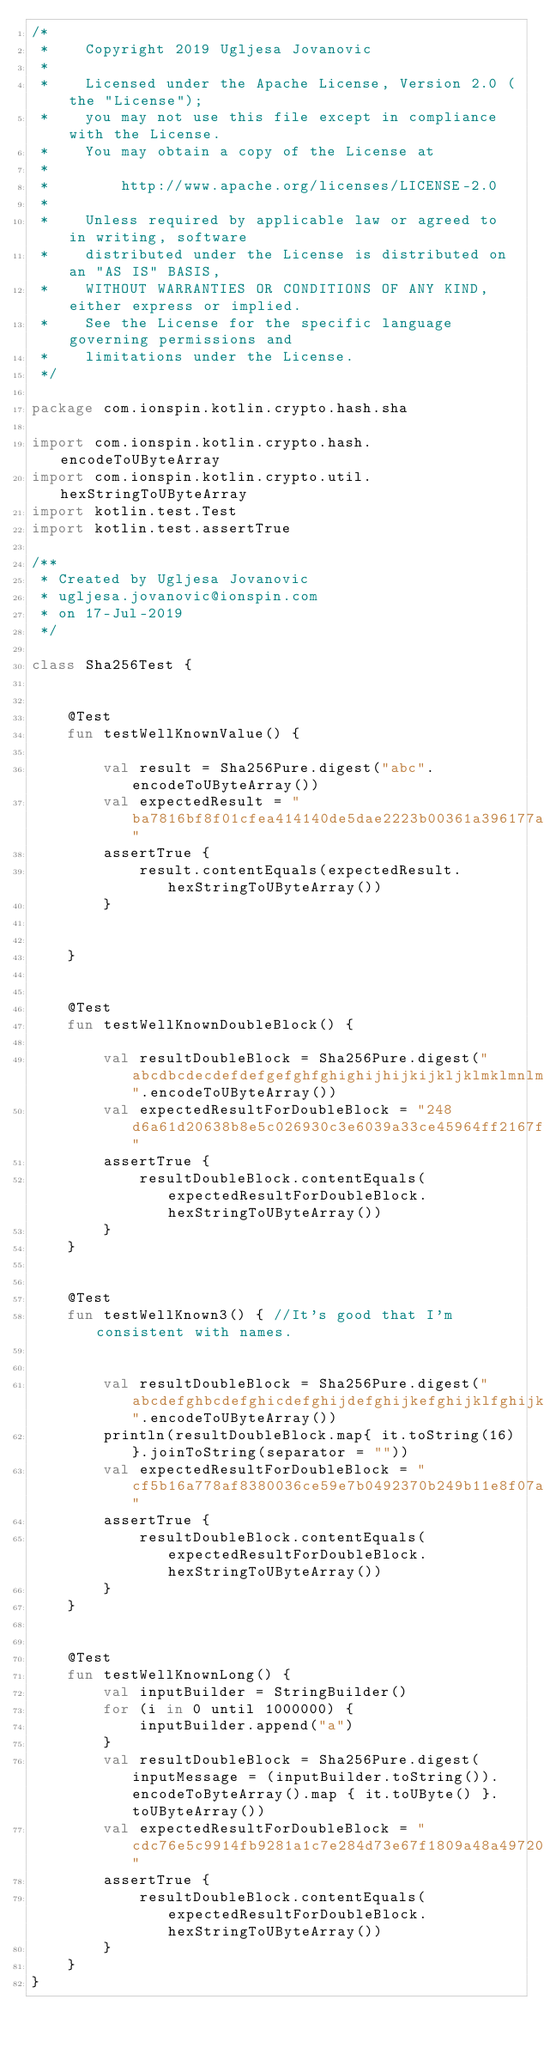<code> <loc_0><loc_0><loc_500><loc_500><_Kotlin_>/*
 *    Copyright 2019 Ugljesa Jovanovic
 *
 *    Licensed under the Apache License, Version 2.0 (the "License");
 *    you may not use this file except in compliance with the License.
 *    You may obtain a copy of the License at
 *
 *        http://www.apache.org/licenses/LICENSE-2.0
 *
 *    Unless required by applicable law or agreed to in writing, software
 *    distributed under the License is distributed on an "AS IS" BASIS,
 *    WITHOUT WARRANTIES OR CONDITIONS OF ANY KIND, either express or implied.
 *    See the License for the specific language governing permissions and
 *    limitations under the License.
 */

package com.ionspin.kotlin.crypto.hash.sha

import com.ionspin.kotlin.crypto.hash.encodeToUByteArray
import com.ionspin.kotlin.crypto.util.hexStringToUByteArray
import kotlin.test.Test
import kotlin.test.assertTrue

/**
 * Created by Ugljesa Jovanovic
 * ugljesa.jovanovic@ionspin.com
 * on 17-Jul-2019
 */

class Sha256Test {


    @Test
    fun testWellKnownValue() {

        val result = Sha256Pure.digest("abc".encodeToUByteArray())
        val expectedResult = "ba7816bf8f01cfea414140de5dae2223b00361a396177a9cb410ff61f20015ad"
        assertTrue {
            result.contentEquals(expectedResult.hexStringToUByteArray())
        }


    }


    @Test
    fun testWellKnownDoubleBlock() {

        val resultDoubleBlock = Sha256Pure.digest("abcdbcdecdefdefgefghfghighijhijkijkljklmklmnlmnomnopnopq".encodeToUByteArray())
        val expectedResultForDoubleBlock = "248d6a61d20638b8e5c026930c3e6039a33ce45964ff2167f6ecedd419db06c1"
        assertTrue {
            resultDoubleBlock.contentEquals(expectedResultForDoubleBlock.hexStringToUByteArray())
        }
    }


    @Test
    fun testWellKnown3() { //It's good that I'm consistent with names.


        val resultDoubleBlock = Sha256Pure.digest("abcdefghbcdefghicdefghijdefghijkefghijklfghijklmghijklmnhijklmnoijklmnopjklmnopqklmnopqrlmnopqrsmnopqrstnopqrstu".encodeToUByteArray())
        println(resultDoubleBlock.map{ it.toString(16)}.joinToString(separator = ""))
        val expectedResultForDoubleBlock = "cf5b16a778af8380036ce59e7b0492370b249b11e8f07a51afac45037afee9d1"
        assertTrue {
            resultDoubleBlock.contentEquals(expectedResultForDoubleBlock.hexStringToUByteArray())
        }
    }


    @Test
    fun testWellKnownLong() {
        val inputBuilder = StringBuilder()
        for (i in 0 until 1000000) {
            inputBuilder.append("a")
        }
        val resultDoubleBlock = Sha256Pure.digest(inputMessage = (inputBuilder.toString()).encodeToByteArray().map { it.toUByte() }.toUByteArray())
        val expectedResultForDoubleBlock = "cdc76e5c9914fb9281a1c7e284d73e67f1809a48a497200e046d39ccc7112cd0"
        assertTrue {
            resultDoubleBlock.contentEquals(expectedResultForDoubleBlock.hexStringToUByteArray())
        }
    }
}
</code> 